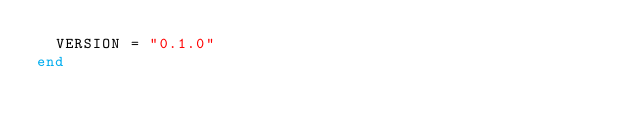Convert code to text. <code><loc_0><loc_0><loc_500><loc_500><_Ruby_>  VERSION = "0.1.0"
end
</code> 